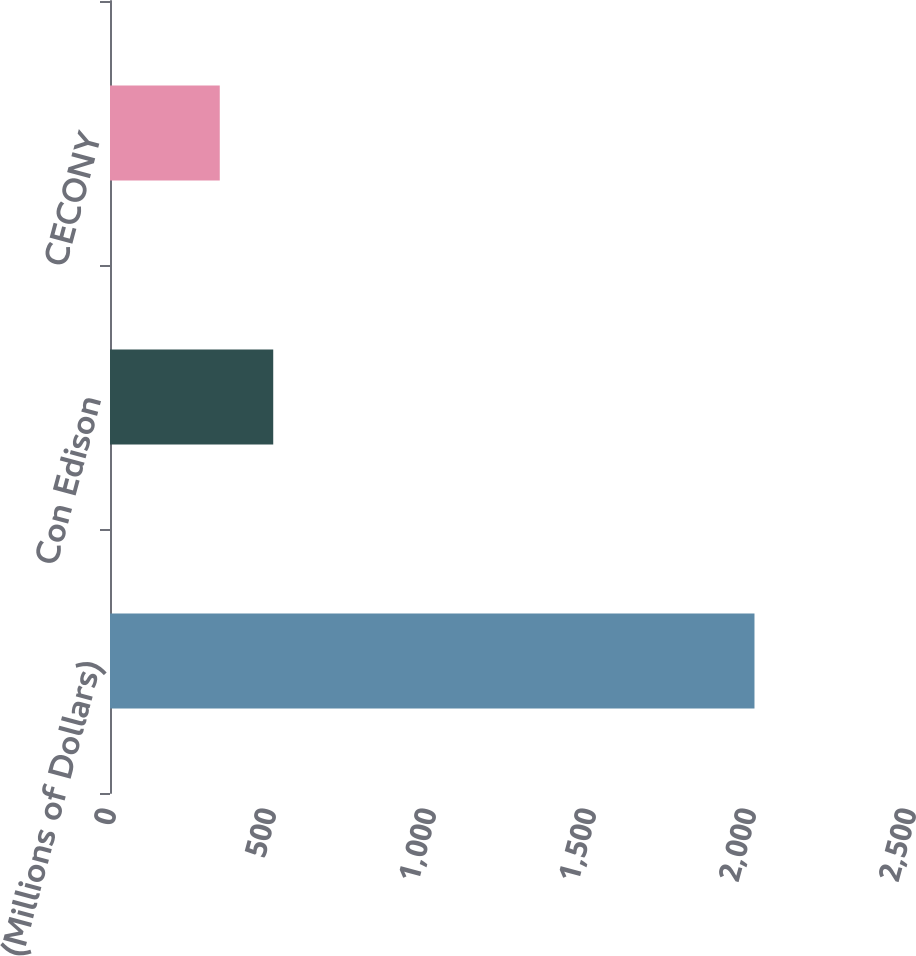Convert chart. <chart><loc_0><loc_0><loc_500><loc_500><bar_chart><fcel>(Millions of Dollars)<fcel>Con Edison<fcel>CECONY<nl><fcel>2014<fcel>510.1<fcel>343<nl></chart> 